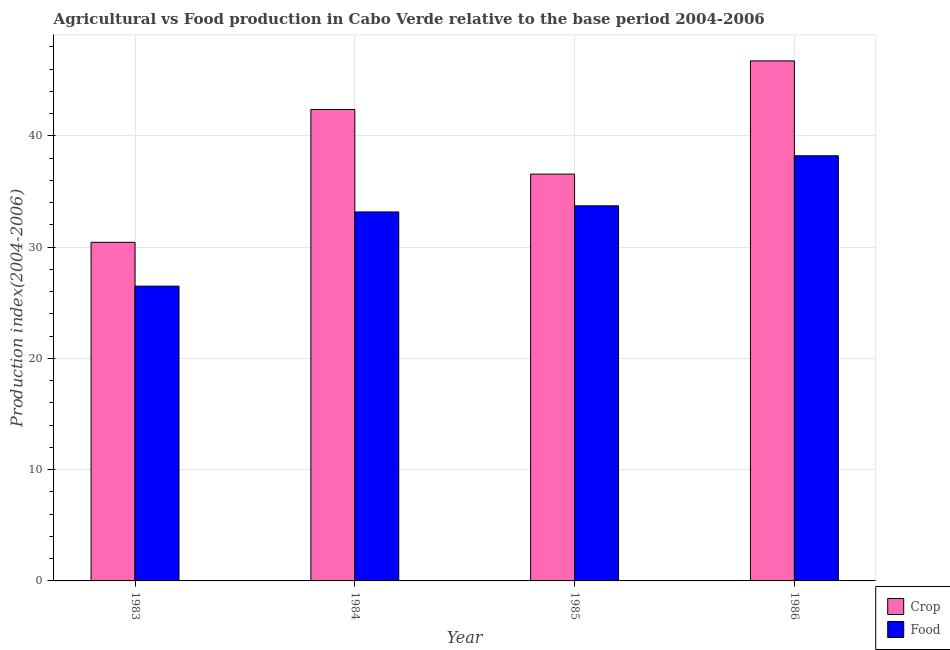How many bars are there on the 1st tick from the left?
Offer a terse response. 2. How many bars are there on the 4th tick from the right?
Offer a terse response. 2. What is the label of the 4th group of bars from the left?
Your answer should be compact. 1986. In how many cases, is the number of bars for a given year not equal to the number of legend labels?
Make the answer very short. 0. What is the food production index in 1983?
Offer a very short reply. 26.5. Across all years, what is the maximum crop production index?
Make the answer very short. 46.75. Across all years, what is the minimum crop production index?
Provide a succinct answer. 30.44. In which year was the crop production index minimum?
Offer a terse response. 1983. What is the total food production index in the graph?
Offer a terse response. 131.61. What is the difference between the food production index in 1983 and that in 1984?
Offer a terse response. -6.67. What is the difference between the crop production index in 1986 and the food production index in 1985?
Offer a terse response. 10.18. What is the average crop production index per year?
Offer a very short reply. 39.04. In how many years, is the crop production index greater than 46?
Provide a short and direct response. 1. What is the ratio of the food production index in 1983 to that in 1984?
Your response must be concise. 0.8. Is the difference between the crop production index in 1984 and 1986 greater than the difference between the food production index in 1984 and 1986?
Offer a very short reply. No. What is the difference between the highest and the second highest crop production index?
Provide a short and direct response. 4.37. What is the difference between the highest and the lowest crop production index?
Your answer should be very brief. 16.31. What does the 2nd bar from the left in 1984 represents?
Your answer should be very brief. Food. What does the 1st bar from the right in 1983 represents?
Your answer should be very brief. Food. Are all the bars in the graph horizontal?
Keep it short and to the point. No. How many years are there in the graph?
Your answer should be compact. 4. What is the title of the graph?
Your answer should be very brief. Agricultural vs Food production in Cabo Verde relative to the base period 2004-2006. Does "Tetanus" appear as one of the legend labels in the graph?
Offer a very short reply. No. What is the label or title of the X-axis?
Your answer should be compact. Year. What is the label or title of the Y-axis?
Give a very brief answer. Production index(2004-2006). What is the Production index(2004-2006) of Crop in 1983?
Offer a terse response. 30.44. What is the Production index(2004-2006) in Crop in 1984?
Give a very brief answer. 42.38. What is the Production index(2004-2006) in Food in 1984?
Your response must be concise. 33.17. What is the Production index(2004-2006) of Crop in 1985?
Your answer should be compact. 36.57. What is the Production index(2004-2006) of Food in 1985?
Give a very brief answer. 33.72. What is the Production index(2004-2006) in Crop in 1986?
Your answer should be very brief. 46.75. What is the Production index(2004-2006) of Food in 1986?
Your answer should be very brief. 38.22. Across all years, what is the maximum Production index(2004-2006) in Crop?
Provide a succinct answer. 46.75. Across all years, what is the maximum Production index(2004-2006) of Food?
Give a very brief answer. 38.22. Across all years, what is the minimum Production index(2004-2006) in Crop?
Give a very brief answer. 30.44. What is the total Production index(2004-2006) of Crop in the graph?
Your answer should be very brief. 156.14. What is the total Production index(2004-2006) of Food in the graph?
Give a very brief answer. 131.61. What is the difference between the Production index(2004-2006) in Crop in 1983 and that in 1984?
Keep it short and to the point. -11.94. What is the difference between the Production index(2004-2006) of Food in 1983 and that in 1984?
Give a very brief answer. -6.67. What is the difference between the Production index(2004-2006) of Crop in 1983 and that in 1985?
Provide a succinct answer. -6.13. What is the difference between the Production index(2004-2006) of Food in 1983 and that in 1985?
Your response must be concise. -7.22. What is the difference between the Production index(2004-2006) in Crop in 1983 and that in 1986?
Offer a terse response. -16.31. What is the difference between the Production index(2004-2006) of Food in 1983 and that in 1986?
Your answer should be very brief. -11.72. What is the difference between the Production index(2004-2006) of Crop in 1984 and that in 1985?
Ensure brevity in your answer.  5.81. What is the difference between the Production index(2004-2006) of Food in 1984 and that in 1985?
Offer a terse response. -0.55. What is the difference between the Production index(2004-2006) in Crop in 1984 and that in 1986?
Your answer should be very brief. -4.37. What is the difference between the Production index(2004-2006) in Food in 1984 and that in 1986?
Your answer should be compact. -5.05. What is the difference between the Production index(2004-2006) in Crop in 1985 and that in 1986?
Your response must be concise. -10.18. What is the difference between the Production index(2004-2006) of Food in 1985 and that in 1986?
Offer a very short reply. -4.5. What is the difference between the Production index(2004-2006) of Crop in 1983 and the Production index(2004-2006) of Food in 1984?
Ensure brevity in your answer.  -2.73. What is the difference between the Production index(2004-2006) in Crop in 1983 and the Production index(2004-2006) in Food in 1985?
Offer a very short reply. -3.28. What is the difference between the Production index(2004-2006) in Crop in 1983 and the Production index(2004-2006) in Food in 1986?
Your answer should be very brief. -7.78. What is the difference between the Production index(2004-2006) in Crop in 1984 and the Production index(2004-2006) in Food in 1985?
Offer a very short reply. 8.66. What is the difference between the Production index(2004-2006) of Crop in 1984 and the Production index(2004-2006) of Food in 1986?
Keep it short and to the point. 4.16. What is the difference between the Production index(2004-2006) in Crop in 1985 and the Production index(2004-2006) in Food in 1986?
Make the answer very short. -1.65. What is the average Production index(2004-2006) in Crop per year?
Your answer should be compact. 39.03. What is the average Production index(2004-2006) of Food per year?
Your answer should be compact. 32.9. In the year 1983, what is the difference between the Production index(2004-2006) in Crop and Production index(2004-2006) in Food?
Ensure brevity in your answer.  3.94. In the year 1984, what is the difference between the Production index(2004-2006) of Crop and Production index(2004-2006) of Food?
Your response must be concise. 9.21. In the year 1985, what is the difference between the Production index(2004-2006) of Crop and Production index(2004-2006) of Food?
Your response must be concise. 2.85. In the year 1986, what is the difference between the Production index(2004-2006) in Crop and Production index(2004-2006) in Food?
Provide a succinct answer. 8.53. What is the ratio of the Production index(2004-2006) of Crop in 1983 to that in 1984?
Ensure brevity in your answer.  0.72. What is the ratio of the Production index(2004-2006) in Food in 1983 to that in 1984?
Provide a succinct answer. 0.8. What is the ratio of the Production index(2004-2006) of Crop in 1983 to that in 1985?
Your answer should be compact. 0.83. What is the ratio of the Production index(2004-2006) in Food in 1983 to that in 1985?
Provide a succinct answer. 0.79. What is the ratio of the Production index(2004-2006) of Crop in 1983 to that in 1986?
Make the answer very short. 0.65. What is the ratio of the Production index(2004-2006) of Food in 1983 to that in 1986?
Give a very brief answer. 0.69. What is the ratio of the Production index(2004-2006) in Crop in 1984 to that in 1985?
Offer a terse response. 1.16. What is the ratio of the Production index(2004-2006) in Food in 1984 to that in 1985?
Provide a short and direct response. 0.98. What is the ratio of the Production index(2004-2006) in Crop in 1984 to that in 1986?
Offer a very short reply. 0.91. What is the ratio of the Production index(2004-2006) in Food in 1984 to that in 1986?
Your answer should be very brief. 0.87. What is the ratio of the Production index(2004-2006) of Crop in 1985 to that in 1986?
Your answer should be compact. 0.78. What is the ratio of the Production index(2004-2006) in Food in 1985 to that in 1986?
Give a very brief answer. 0.88. What is the difference between the highest and the second highest Production index(2004-2006) in Crop?
Make the answer very short. 4.37. What is the difference between the highest and the second highest Production index(2004-2006) of Food?
Provide a succinct answer. 4.5. What is the difference between the highest and the lowest Production index(2004-2006) in Crop?
Give a very brief answer. 16.31. What is the difference between the highest and the lowest Production index(2004-2006) of Food?
Your answer should be compact. 11.72. 